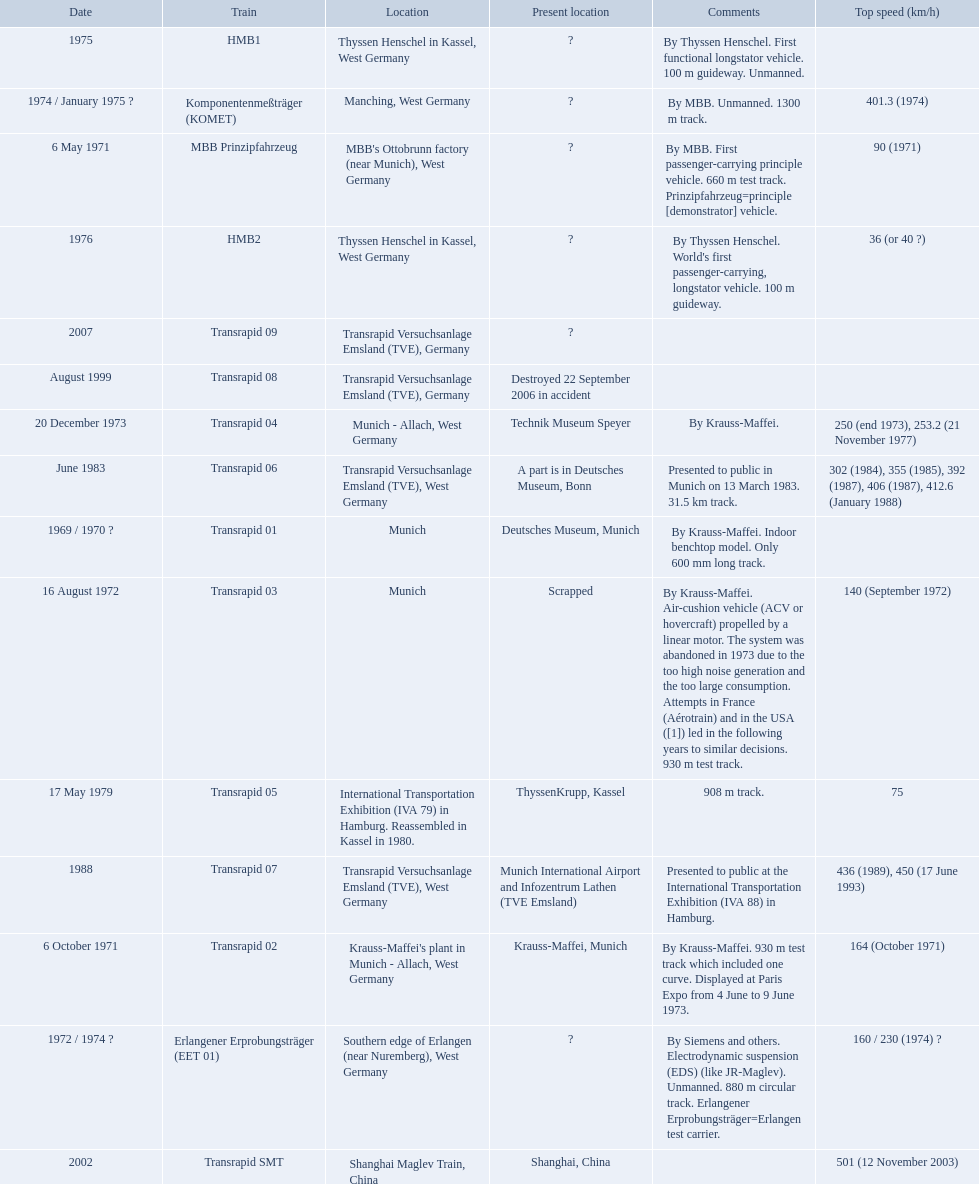What is the top speed reached by any trains shown here? 501 (12 November 2003). What train has reached a top speed of 501? Transrapid SMT. 